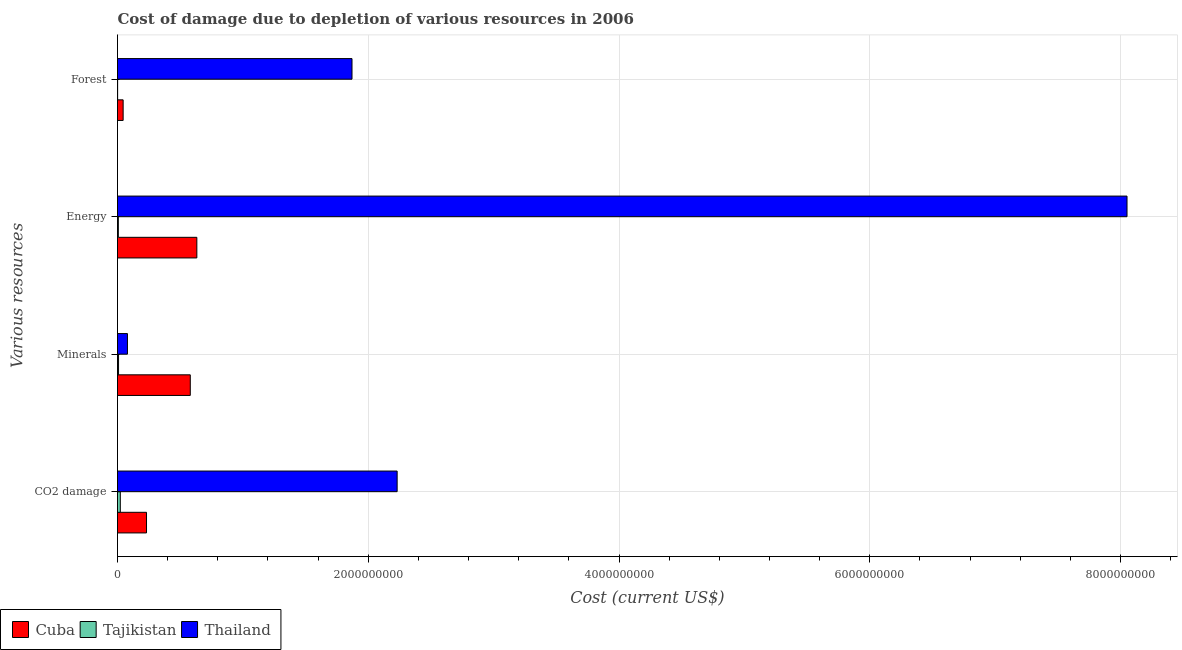Are the number of bars per tick equal to the number of legend labels?
Your response must be concise. Yes. What is the label of the 2nd group of bars from the top?
Offer a very short reply. Energy. What is the cost of damage due to depletion of coal in Tajikistan?
Give a very brief answer. 2.24e+07. Across all countries, what is the maximum cost of damage due to depletion of minerals?
Give a very brief answer. 5.80e+08. Across all countries, what is the minimum cost of damage due to depletion of minerals?
Offer a terse response. 8.32e+06. In which country was the cost of damage due to depletion of energy maximum?
Provide a succinct answer. Thailand. In which country was the cost of damage due to depletion of forests minimum?
Give a very brief answer. Tajikistan. What is the total cost of damage due to depletion of coal in the graph?
Offer a very short reply. 2.48e+09. What is the difference between the cost of damage due to depletion of energy in Thailand and that in Cuba?
Your response must be concise. 7.42e+09. What is the difference between the cost of damage due to depletion of coal in Tajikistan and the cost of damage due to depletion of minerals in Thailand?
Make the answer very short. -5.69e+07. What is the average cost of damage due to depletion of coal per country?
Ensure brevity in your answer.  8.28e+08. What is the difference between the cost of damage due to depletion of forests and cost of damage due to depletion of energy in Cuba?
Your answer should be very brief. -5.88e+08. What is the ratio of the cost of damage due to depletion of minerals in Cuba to that in Tajikistan?
Ensure brevity in your answer.  69.73. Is the cost of damage due to depletion of minerals in Thailand less than that in Tajikistan?
Your answer should be very brief. No. What is the difference between the highest and the second highest cost of damage due to depletion of coal?
Your answer should be compact. 2.00e+09. What is the difference between the highest and the lowest cost of damage due to depletion of coal?
Give a very brief answer. 2.21e+09. In how many countries, is the cost of damage due to depletion of coal greater than the average cost of damage due to depletion of coal taken over all countries?
Offer a very short reply. 1. What does the 1st bar from the top in Minerals represents?
Ensure brevity in your answer.  Thailand. What does the 2nd bar from the bottom in Forest represents?
Your response must be concise. Tajikistan. Is it the case that in every country, the sum of the cost of damage due to depletion of coal and cost of damage due to depletion of minerals is greater than the cost of damage due to depletion of energy?
Offer a terse response. No. How many bars are there?
Ensure brevity in your answer.  12. How many countries are there in the graph?
Your response must be concise. 3. Does the graph contain any zero values?
Give a very brief answer. No. Where does the legend appear in the graph?
Keep it short and to the point. Bottom left. How many legend labels are there?
Your response must be concise. 3. How are the legend labels stacked?
Your response must be concise. Horizontal. What is the title of the graph?
Your response must be concise. Cost of damage due to depletion of various resources in 2006 . What is the label or title of the X-axis?
Offer a very short reply. Cost (current US$). What is the label or title of the Y-axis?
Provide a short and direct response. Various resources. What is the Cost (current US$) in Cuba in CO2 damage?
Provide a short and direct response. 2.31e+08. What is the Cost (current US$) in Tajikistan in CO2 damage?
Your answer should be very brief. 2.24e+07. What is the Cost (current US$) of Thailand in CO2 damage?
Your response must be concise. 2.23e+09. What is the Cost (current US$) in Cuba in Minerals?
Your answer should be very brief. 5.80e+08. What is the Cost (current US$) of Tajikistan in Minerals?
Keep it short and to the point. 8.32e+06. What is the Cost (current US$) of Thailand in Minerals?
Provide a short and direct response. 7.94e+07. What is the Cost (current US$) in Cuba in Energy?
Keep it short and to the point. 6.33e+08. What is the Cost (current US$) in Tajikistan in Energy?
Give a very brief answer. 6.75e+06. What is the Cost (current US$) of Thailand in Energy?
Provide a succinct answer. 8.05e+09. What is the Cost (current US$) in Cuba in Forest?
Provide a succinct answer. 4.49e+07. What is the Cost (current US$) in Tajikistan in Forest?
Keep it short and to the point. 9.51e+05. What is the Cost (current US$) of Thailand in Forest?
Your answer should be very brief. 1.87e+09. Across all Various resources, what is the maximum Cost (current US$) of Cuba?
Keep it short and to the point. 6.33e+08. Across all Various resources, what is the maximum Cost (current US$) of Tajikistan?
Ensure brevity in your answer.  2.24e+07. Across all Various resources, what is the maximum Cost (current US$) in Thailand?
Your response must be concise. 8.05e+09. Across all Various resources, what is the minimum Cost (current US$) in Cuba?
Your answer should be very brief. 4.49e+07. Across all Various resources, what is the minimum Cost (current US$) of Tajikistan?
Give a very brief answer. 9.51e+05. Across all Various resources, what is the minimum Cost (current US$) in Thailand?
Your answer should be very brief. 7.94e+07. What is the total Cost (current US$) in Cuba in the graph?
Make the answer very short. 1.49e+09. What is the total Cost (current US$) in Tajikistan in the graph?
Give a very brief answer. 3.85e+07. What is the total Cost (current US$) of Thailand in the graph?
Your response must be concise. 1.22e+1. What is the difference between the Cost (current US$) in Cuba in CO2 damage and that in Minerals?
Your answer should be compact. -3.49e+08. What is the difference between the Cost (current US$) in Tajikistan in CO2 damage and that in Minerals?
Give a very brief answer. 1.41e+07. What is the difference between the Cost (current US$) in Thailand in CO2 damage and that in Minerals?
Provide a short and direct response. 2.15e+09. What is the difference between the Cost (current US$) in Cuba in CO2 damage and that in Energy?
Make the answer very short. -4.01e+08. What is the difference between the Cost (current US$) of Tajikistan in CO2 damage and that in Energy?
Give a very brief answer. 1.57e+07. What is the difference between the Cost (current US$) in Thailand in CO2 damage and that in Energy?
Offer a very short reply. -5.82e+09. What is the difference between the Cost (current US$) of Cuba in CO2 damage and that in Forest?
Your response must be concise. 1.86e+08. What is the difference between the Cost (current US$) in Tajikistan in CO2 damage and that in Forest?
Offer a very short reply. 2.15e+07. What is the difference between the Cost (current US$) of Thailand in CO2 damage and that in Forest?
Ensure brevity in your answer.  3.60e+08. What is the difference between the Cost (current US$) of Cuba in Minerals and that in Energy?
Provide a succinct answer. -5.23e+07. What is the difference between the Cost (current US$) in Tajikistan in Minerals and that in Energy?
Ensure brevity in your answer.  1.58e+06. What is the difference between the Cost (current US$) of Thailand in Minerals and that in Energy?
Your response must be concise. -7.97e+09. What is the difference between the Cost (current US$) in Cuba in Minerals and that in Forest?
Give a very brief answer. 5.36e+08. What is the difference between the Cost (current US$) in Tajikistan in Minerals and that in Forest?
Your answer should be very brief. 7.37e+06. What is the difference between the Cost (current US$) in Thailand in Minerals and that in Forest?
Keep it short and to the point. -1.79e+09. What is the difference between the Cost (current US$) in Cuba in Energy and that in Forest?
Offer a very short reply. 5.88e+08. What is the difference between the Cost (current US$) in Tajikistan in Energy and that in Forest?
Make the answer very short. 5.80e+06. What is the difference between the Cost (current US$) in Thailand in Energy and that in Forest?
Your answer should be very brief. 6.18e+09. What is the difference between the Cost (current US$) in Cuba in CO2 damage and the Cost (current US$) in Tajikistan in Minerals?
Your response must be concise. 2.23e+08. What is the difference between the Cost (current US$) of Cuba in CO2 damage and the Cost (current US$) of Thailand in Minerals?
Keep it short and to the point. 1.52e+08. What is the difference between the Cost (current US$) of Tajikistan in CO2 damage and the Cost (current US$) of Thailand in Minerals?
Keep it short and to the point. -5.69e+07. What is the difference between the Cost (current US$) of Cuba in CO2 damage and the Cost (current US$) of Tajikistan in Energy?
Give a very brief answer. 2.25e+08. What is the difference between the Cost (current US$) of Cuba in CO2 damage and the Cost (current US$) of Thailand in Energy?
Offer a terse response. -7.82e+09. What is the difference between the Cost (current US$) of Tajikistan in CO2 damage and the Cost (current US$) of Thailand in Energy?
Offer a very short reply. -8.03e+09. What is the difference between the Cost (current US$) in Cuba in CO2 damage and the Cost (current US$) in Tajikistan in Forest?
Keep it short and to the point. 2.30e+08. What is the difference between the Cost (current US$) of Cuba in CO2 damage and the Cost (current US$) of Thailand in Forest?
Offer a terse response. -1.64e+09. What is the difference between the Cost (current US$) in Tajikistan in CO2 damage and the Cost (current US$) in Thailand in Forest?
Make the answer very short. -1.85e+09. What is the difference between the Cost (current US$) in Cuba in Minerals and the Cost (current US$) in Tajikistan in Energy?
Make the answer very short. 5.74e+08. What is the difference between the Cost (current US$) of Cuba in Minerals and the Cost (current US$) of Thailand in Energy?
Give a very brief answer. -7.47e+09. What is the difference between the Cost (current US$) of Tajikistan in Minerals and the Cost (current US$) of Thailand in Energy?
Ensure brevity in your answer.  -8.04e+09. What is the difference between the Cost (current US$) of Cuba in Minerals and the Cost (current US$) of Tajikistan in Forest?
Your answer should be compact. 5.80e+08. What is the difference between the Cost (current US$) in Cuba in Minerals and the Cost (current US$) in Thailand in Forest?
Give a very brief answer. -1.29e+09. What is the difference between the Cost (current US$) in Tajikistan in Minerals and the Cost (current US$) in Thailand in Forest?
Provide a short and direct response. -1.86e+09. What is the difference between the Cost (current US$) in Cuba in Energy and the Cost (current US$) in Tajikistan in Forest?
Your answer should be very brief. 6.32e+08. What is the difference between the Cost (current US$) in Cuba in Energy and the Cost (current US$) in Thailand in Forest?
Offer a very short reply. -1.24e+09. What is the difference between the Cost (current US$) of Tajikistan in Energy and the Cost (current US$) of Thailand in Forest?
Your answer should be compact. -1.86e+09. What is the average Cost (current US$) in Cuba per Various resources?
Your answer should be compact. 3.72e+08. What is the average Cost (current US$) in Tajikistan per Various resources?
Your response must be concise. 9.62e+06. What is the average Cost (current US$) in Thailand per Various resources?
Your response must be concise. 3.06e+09. What is the difference between the Cost (current US$) in Cuba and Cost (current US$) in Tajikistan in CO2 damage?
Offer a terse response. 2.09e+08. What is the difference between the Cost (current US$) in Cuba and Cost (current US$) in Thailand in CO2 damage?
Your answer should be compact. -2.00e+09. What is the difference between the Cost (current US$) in Tajikistan and Cost (current US$) in Thailand in CO2 damage?
Give a very brief answer. -2.21e+09. What is the difference between the Cost (current US$) of Cuba and Cost (current US$) of Tajikistan in Minerals?
Provide a short and direct response. 5.72e+08. What is the difference between the Cost (current US$) of Cuba and Cost (current US$) of Thailand in Minerals?
Make the answer very short. 5.01e+08. What is the difference between the Cost (current US$) in Tajikistan and Cost (current US$) in Thailand in Minerals?
Keep it short and to the point. -7.10e+07. What is the difference between the Cost (current US$) of Cuba and Cost (current US$) of Tajikistan in Energy?
Offer a terse response. 6.26e+08. What is the difference between the Cost (current US$) in Cuba and Cost (current US$) in Thailand in Energy?
Your answer should be compact. -7.42e+09. What is the difference between the Cost (current US$) of Tajikistan and Cost (current US$) of Thailand in Energy?
Offer a terse response. -8.05e+09. What is the difference between the Cost (current US$) in Cuba and Cost (current US$) in Tajikistan in Forest?
Make the answer very short. 4.40e+07. What is the difference between the Cost (current US$) in Cuba and Cost (current US$) in Thailand in Forest?
Your answer should be compact. -1.83e+09. What is the difference between the Cost (current US$) in Tajikistan and Cost (current US$) in Thailand in Forest?
Provide a short and direct response. -1.87e+09. What is the ratio of the Cost (current US$) in Cuba in CO2 damage to that in Minerals?
Make the answer very short. 0.4. What is the ratio of the Cost (current US$) in Tajikistan in CO2 damage to that in Minerals?
Offer a very short reply. 2.7. What is the ratio of the Cost (current US$) in Thailand in CO2 damage to that in Minerals?
Ensure brevity in your answer.  28.1. What is the ratio of the Cost (current US$) in Cuba in CO2 damage to that in Energy?
Offer a terse response. 0.37. What is the ratio of the Cost (current US$) in Tajikistan in CO2 damage to that in Energy?
Your answer should be compact. 3.33. What is the ratio of the Cost (current US$) of Thailand in CO2 damage to that in Energy?
Offer a very short reply. 0.28. What is the ratio of the Cost (current US$) of Cuba in CO2 damage to that in Forest?
Your answer should be very brief. 5.15. What is the ratio of the Cost (current US$) in Tajikistan in CO2 damage to that in Forest?
Offer a terse response. 23.59. What is the ratio of the Cost (current US$) in Thailand in CO2 damage to that in Forest?
Your response must be concise. 1.19. What is the ratio of the Cost (current US$) of Cuba in Minerals to that in Energy?
Give a very brief answer. 0.92. What is the ratio of the Cost (current US$) of Tajikistan in Minerals to that in Energy?
Provide a short and direct response. 1.23. What is the ratio of the Cost (current US$) of Thailand in Minerals to that in Energy?
Give a very brief answer. 0.01. What is the ratio of the Cost (current US$) of Cuba in Minerals to that in Forest?
Your response must be concise. 12.92. What is the ratio of the Cost (current US$) in Tajikistan in Minerals to that in Forest?
Provide a succinct answer. 8.75. What is the ratio of the Cost (current US$) of Thailand in Minerals to that in Forest?
Offer a terse response. 0.04. What is the ratio of the Cost (current US$) of Cuba in Energy to that in Forest?
Keep it short and to the point. 14.08. What is the ratio of the Cost (current US$) of Tajikistan in Energy to that in Forest?
Offer a very short reply. 7.09. What is the ratio of the Cost (current US$) in Thailand in Energy to that in Forest?
Give a very brief answer. 4.3. What is the difference between the highest and the second highest Cost (current US$) in Cuba?
Provide a succinct answer. 5.23e+07. What is the difference between the highest and the second highest Cost (current US$) in Tajikistan?
Provide a short and direct response. 1.41e+07. What is the difference between the highest and the second highest Cost (current US$) of Thailand?
Provide a succinct answer. 5.82e+09. What is the difference between the highest and the lowest Cost (current US$) in Cuba?
Make the answer very short. 5.88e+08. What is the difference between the highest and the lowest Cost (current US$) of Tajikistan?
Give a very brief answer. 2.15e+07. What is the difference between the highest and the lowest Cost (current US$) in Thailand?
Provide a succinct answer. 7.97e+09. 